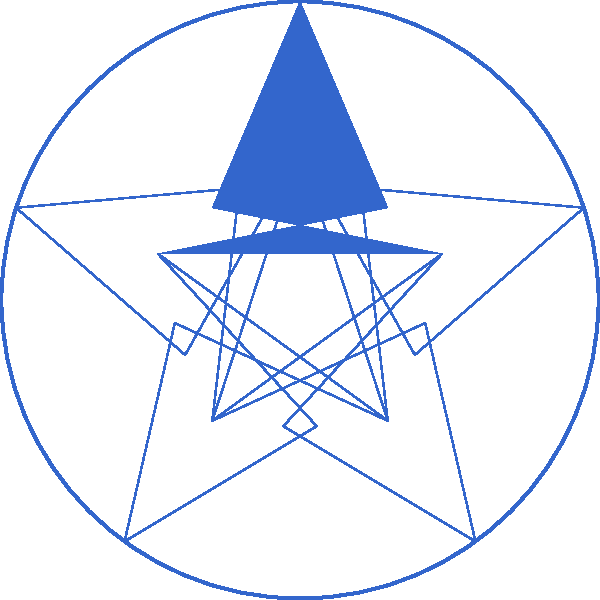Considering the political party logo shown above, which consists of a circle containing five regularly spaced five-pointed stars, what is the order of its symmetry group? To determine the order of the symmetry group for this logo, we need to count all the symmetry operations that leave the logo unchanged. Let's break it down step-by-step:

1. Rotational symmetry:
   - The logo has 5-fold rotational symmetry, meaning it remains unchanged when rotated by multiples of 72° (360°/5).
   - This gives us 5 rotational symmetries (including the identity rotation of 0°).

2. Reflection symmetry:
   - There are 5 lines of reflection, each passing through the center of the circle and the point of one star.

3. Total number of symmetries:
   - The total number of symmetries is the sum of rotational and reflectional symmetries.
   - However, this is equivalent to the number of rotational symmetries multiplied by 2 (as each rotation can be followed by either no reflection or a reflection).

4. Calculating the order:
   - Order of the symmetry group = Number of rotations × 2
   - Order = 5 × 2 = 10

Therefore, the symmetry group of this logo is the dihedral group $D_5$, which has an order of 10.
Answer: 10 